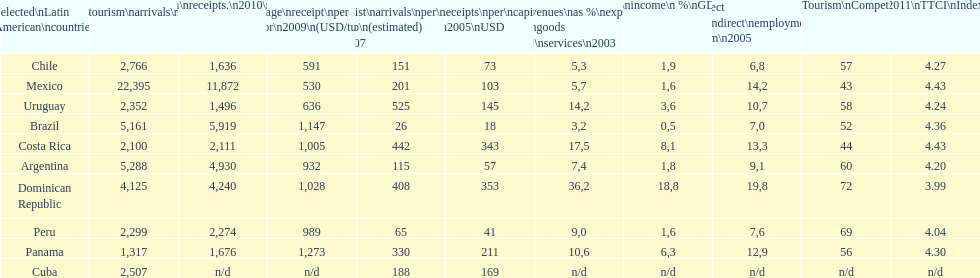Which nation had the lowest tourism revenue in 2003? Brazil. 